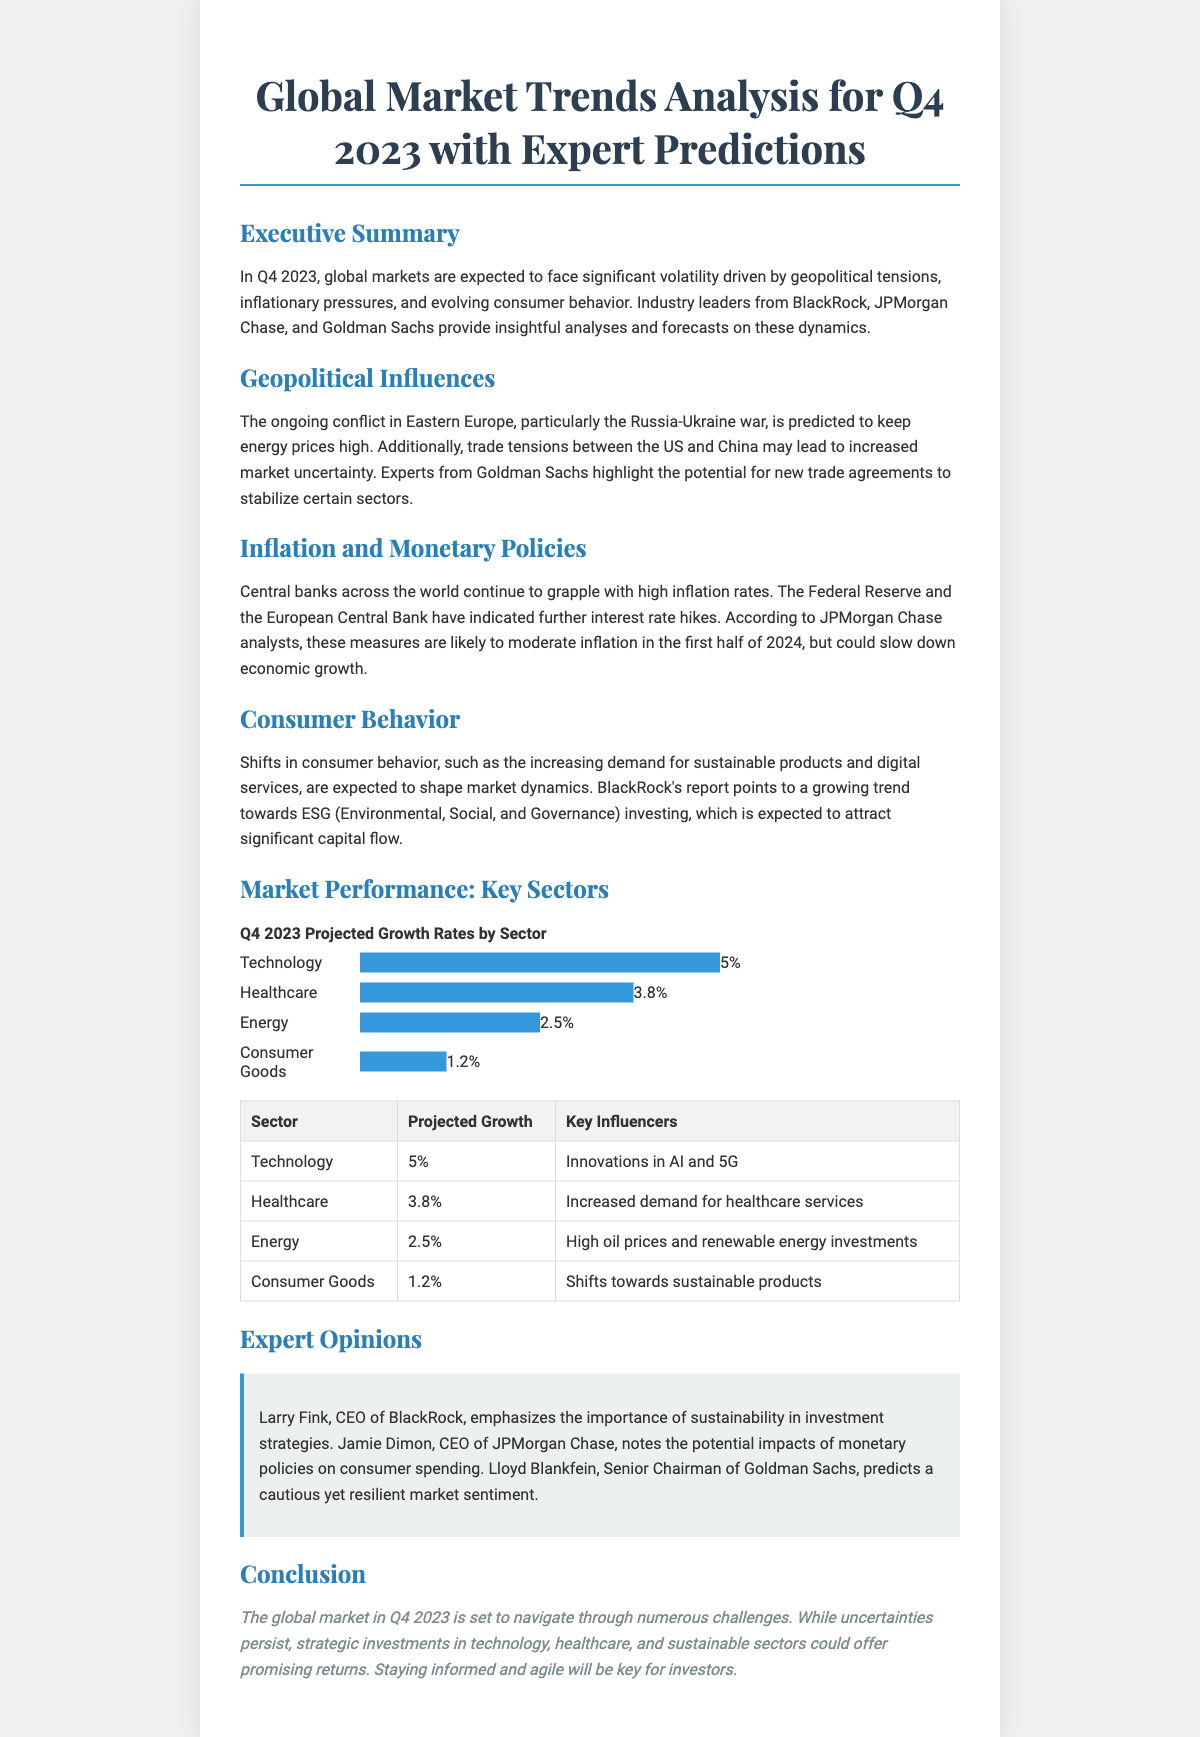What is the projected growth rate for Technology? The document lists Technology's projected growth rate as 5%.
Answer: 5% Who emphasizes sustainability in investment strategies? Larry Fink, CEO of BlackRock, emphasizes sustainability.
Answer: Larry Fink What are the key influencers for the Healthcare sector? Increased demand for healthcare services is noted as the key influencer for Healthcare.
Answer: Increased demand for healthcare services What is the predicted impact of monetary policies according to Jamie Dimon? Jamie Dimon notes potential impacts on consumer spending due to monetary policies.
Answer: Consumer spending What is the anticipated growth rate for Consumer Goods? The document states that the projected growth rate for Consumer Goods is 1.2%.
Answer: 1.2% 